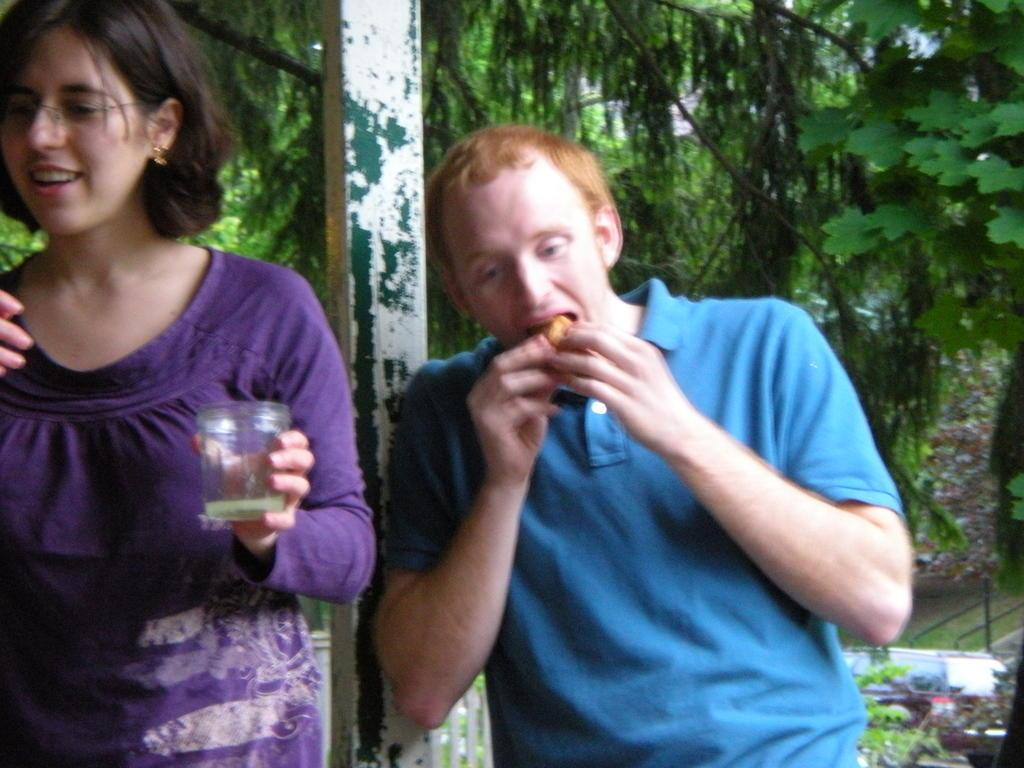How many people are present in the image? There are two people in the image. What can be seen in the image besides the people? There is a glass, food, poles, and some objects in the image. What is the background of the image? There are trees in the background of the image. What type of polish is being applied to the icicle in the image? There is no icicle or polish present in the image. 